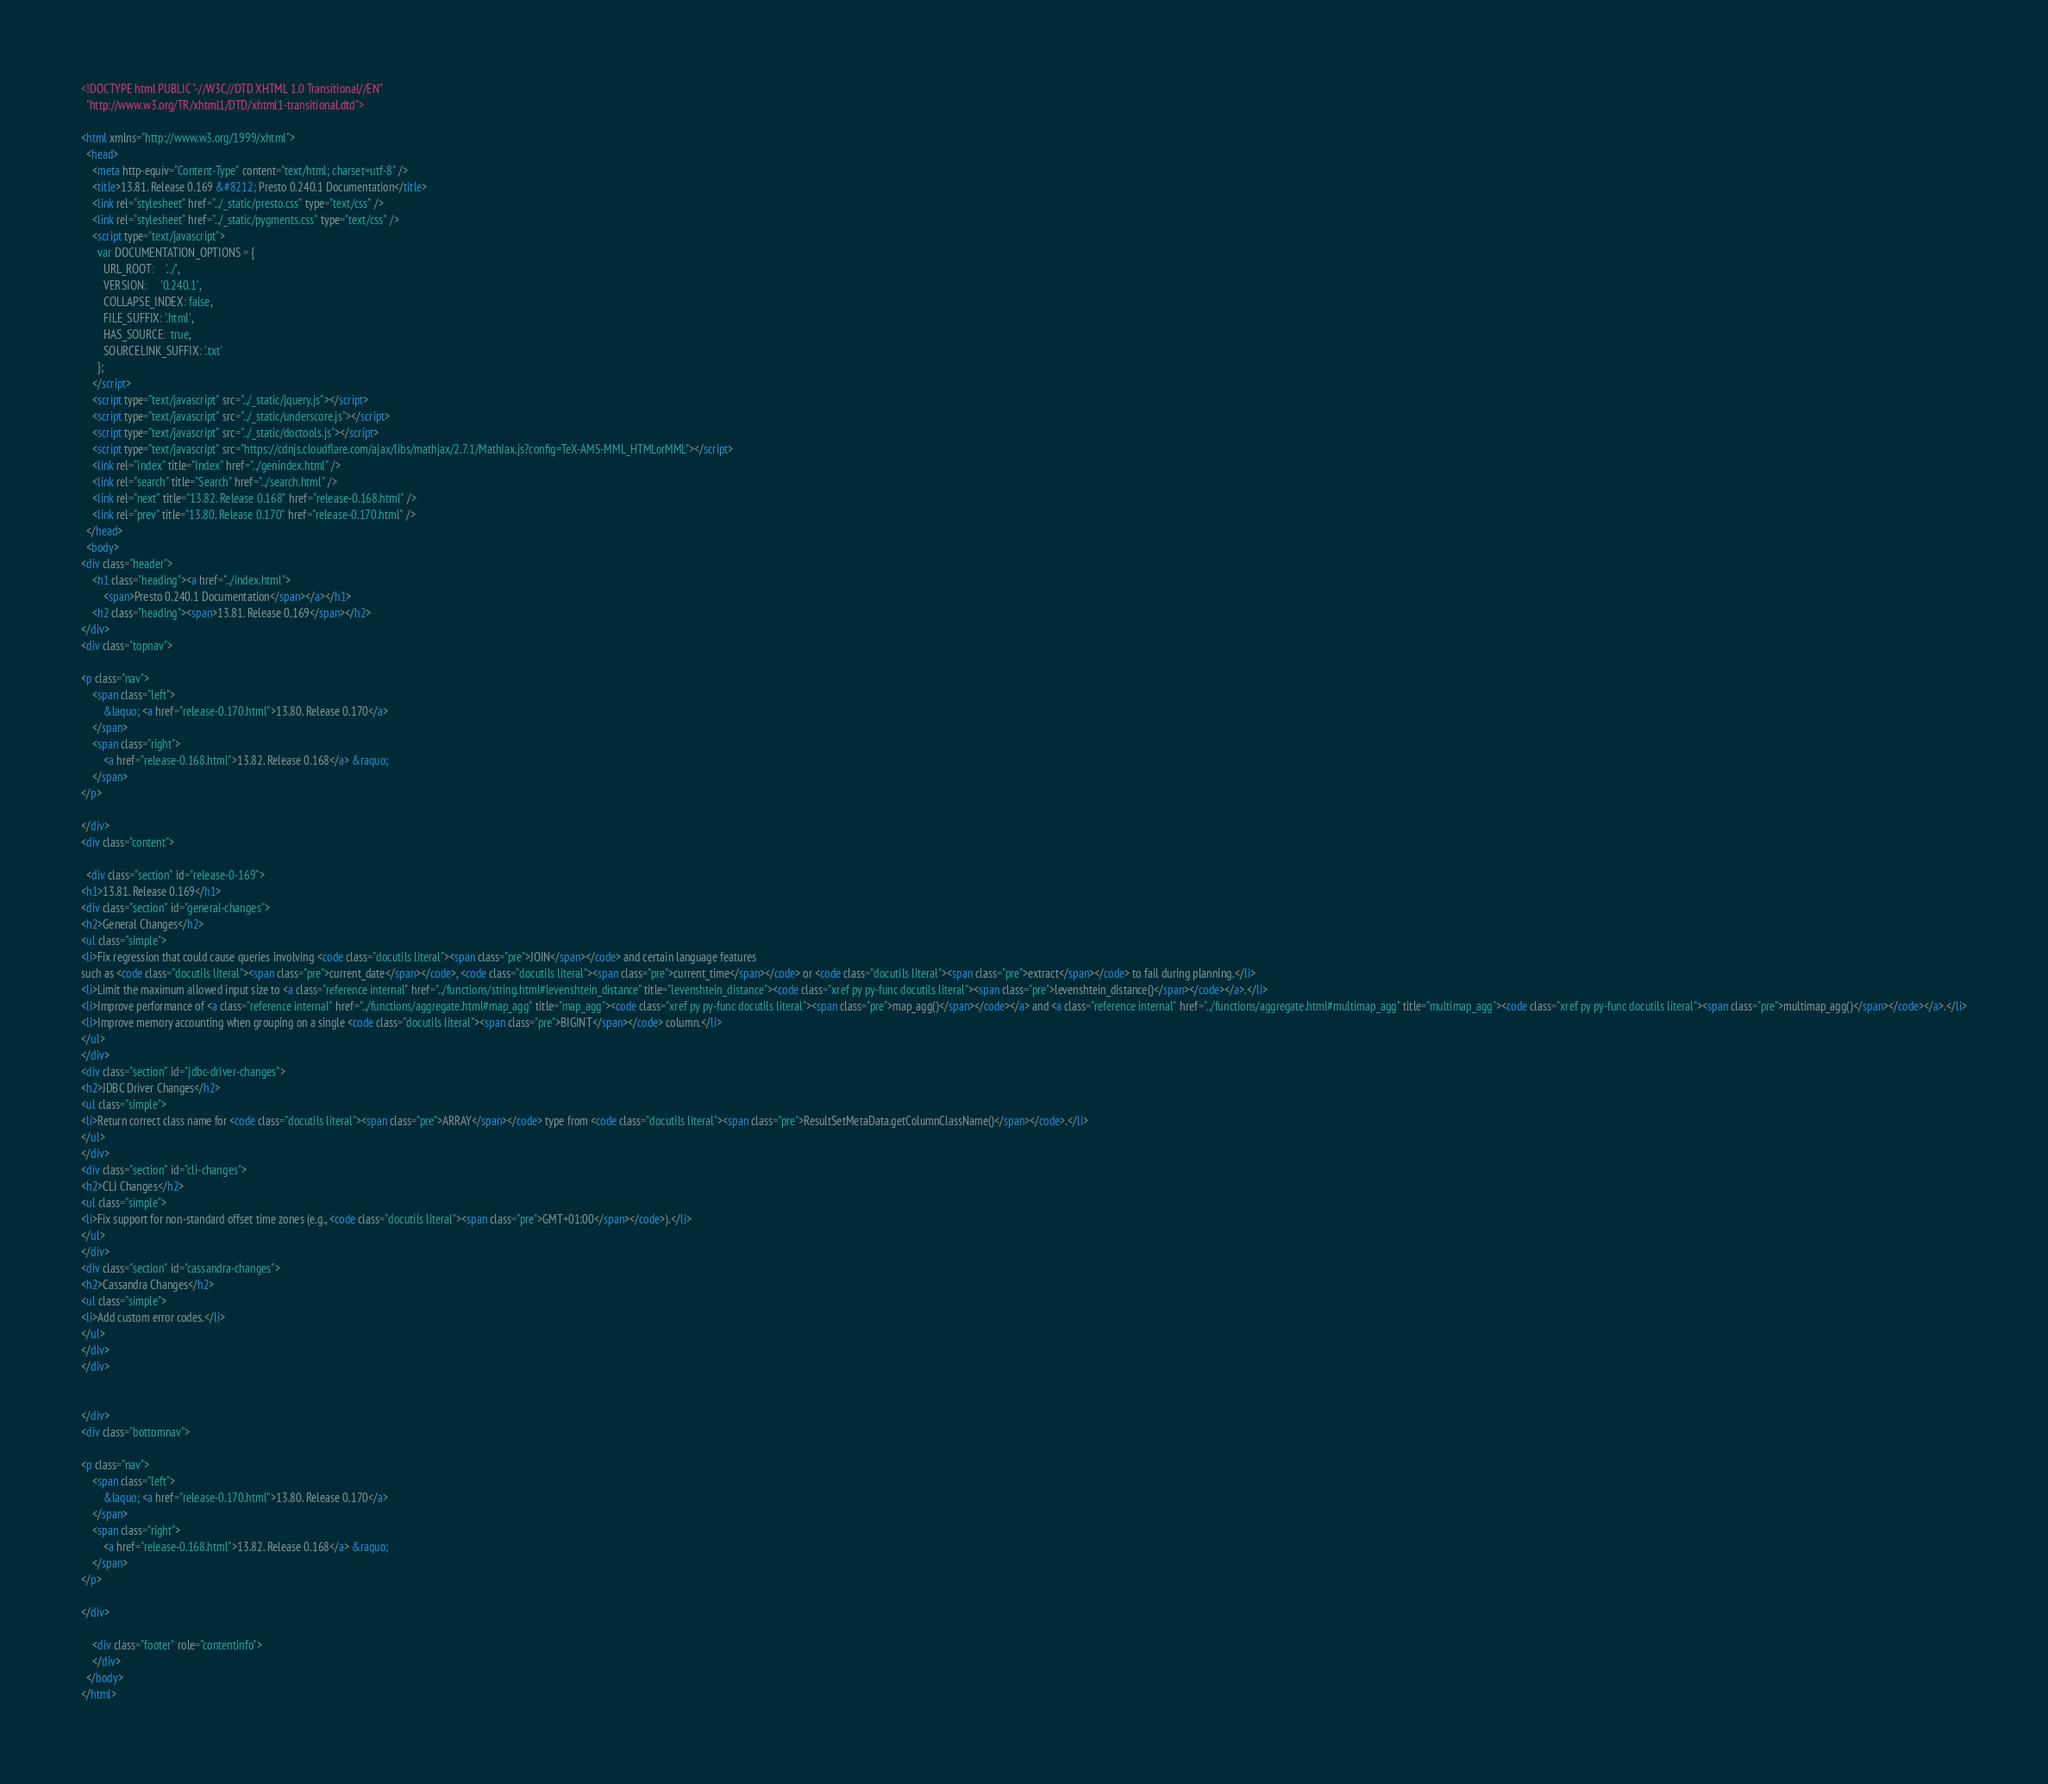Convert code to text. <code><loc_0><loc_0><loc_500><loc_500><_HTML_>
<!DOCTYPE html PUBLIC "-//W3C//DTD XHTML 1.0 Transitional//EN"
  "http://www.w3.org/TR/xhtml1/DTD/xhtml1-transitional.dtd">

<html xmlns="http://www.w3.org/1999/xhtml">
  <head>
    <meta http-equiv="Content-Type" content="text/html; charset=utf-8" />
    <title>13.81. Release 0.169 &#8212; Presto 0.240.1 Documentation</title>
    <link rel="stylesheet" href="../_static/presto.css" type="text/css" />
    <link rel="stylesheet" href="../_static/pygments.css" type="text/css" />
    <script type="text/javascript">
      var DOCUMENTATION_OPTIONS = {
        URL_ROOT:    '../',
        VERSION:     '0.240.1',
        COLLAPSE_INDEX: false,
        FILE_SUFFIX: '.html',
        HAS_SOURCE:  true,
        SOURCELINK_SUFFIX: '.txt'
      };
    </script>
    <script type="text/javascript" src="../_static/jquery.js"></script>
    <script type="text/javascript" src="../_static/underscore.js"></script>
    <script type="text/javascript" src="../_static/doctools.js"></script>
    <script type="text/javascript" src="https://cdnjs.cloudflare.com/ajax/libs/mathjax/2.7.1/MathJax.js?config=TeX-AMS-MML_HTMLorMML"></script>
    <link rel="index" title="Index" href="../genindex.html" />
    <link rel="search" title="Search" href="../search.html" />
    <link rel="next" title="13.82. Release 0.168" href="release-0.168.html" />
    <link rel="prev" title="13.80. Release 0.170" href="release-0.170.html" /> 
  </head>
  <body>
<div class="header">
    <h1 class="heading"><a href="../index.html">
        <span>Presto 0.240.1 Documentation</span></a></h1>
    <h2 class="heading"><span>13.81. Release 0.169</span></h2>
</div>
<div class="topnav">
    
<p class="nav">
    <span class="left">
        &laquo; <a href="release-0.170.html">13.80. Release 0.170</a>
    </span>
    <span class="right">
        <a href="release-0.168.html">13.82. Release 0.168</a> &raquo;
    </span>
</p>

</div>
<div class="content">
    
  <div class="section" id="release-0-169">
<h1>13.81. Release 0.169</h1>
<div class="section" id="general-changes">
<h2>General Changes</h2>
<ul class="simple">
<li>Fix regression that could cause queries involving <code class="docutils literal"><span class="pre">JOIN</span></code> and certain language features
such as <code class="docutils literal"><span class="pre">current_date</span></code>, <code class="docutils literal"><span class="pre">current_time</span></code> or <code class="docutils literal"><span class="pre">extract</span></code> to fail during planning.</li>
<li>Limit the maximum allowed input size to <a class="reference internal" href="../functions/string.html#levenshtein_distance" title="levenshtein_distance"><code class="xref py py-func docutils literal"><span class="pre">levenshtein_distance()</span></code></a>.</li>
<li>Improve performance of <a class="reference internal" href="../functions/aggregate.html#map_agg" title="map_agg"><code class="xref py py-func docutils literal"><span class="pre">map_agg()</span></code></a> and <a class="reference internal" href="../functions/aggregate.html#multimap_agg" title="multimap_agg"><code class="xref py py-func docutils literal"><span class="pre">multimap_agg()</span></code></a>.</li>
<li>Improve memory accounting when grouping on a single <code class="docutils literal"><span class="pre">BIGINT</span></code> column.</li>
</ul>
</div>
<div class="section" id="jdbc-driver-changes">
<h2>JDBC Driver Changes</h2>
<ul class="simple">
<li>Return correct class name for <code class="docutils literal"><span class="pre">ARRAY</span></code> type from <code class="docutils literal"><span class="pre">ResultSetMetaData.getColumnClassName()</span></code>.</li>
</ul>
</div>
<div class="section" id="cli-changes">
<h2>CLI Changes</h2>
<ul class="simple">
<li>Fix support for non-standard offset time zones (e.g., <code class="docutils literal"><span class="pre">GMT+01:00</span></code>).</li>
</ul>
</div>
<div class="section" id="cassandra-changes">
<h2>Cassandra Changes</h2>
<ul class="simple">
<li>Add custom error codes.</li>
</ul>
</div>
</div>


</div>
<div class="bottomnav">
    
<p class="nav">
    <span class="left">
        &laquo; <a href="release-0.170.html">13.80. Release 0.170</a>
    </span>
    <span class="right">
        <a href="release-0.168.html">13.82. Release 0.168</a> &raquo;
    </span>
</p>

</div>

    <div class="footer" role="contentinfo">
    </div>
  </body>
</html></code> 